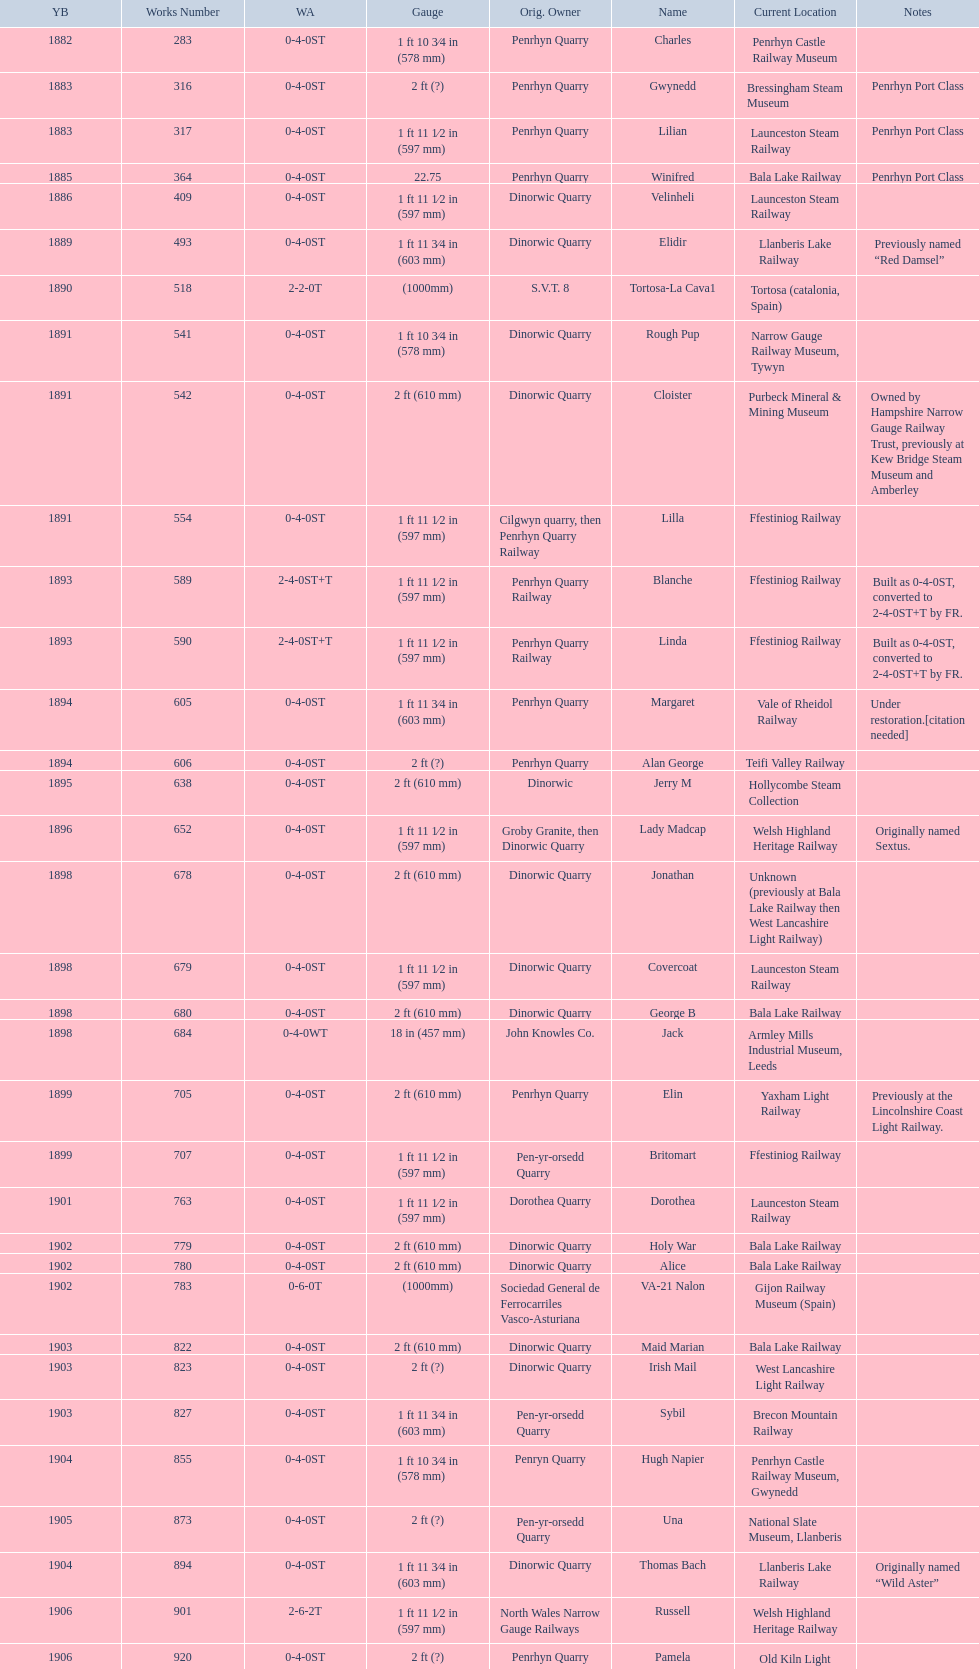Which original owner had the most locomotives? Penrhyn Quarry. 